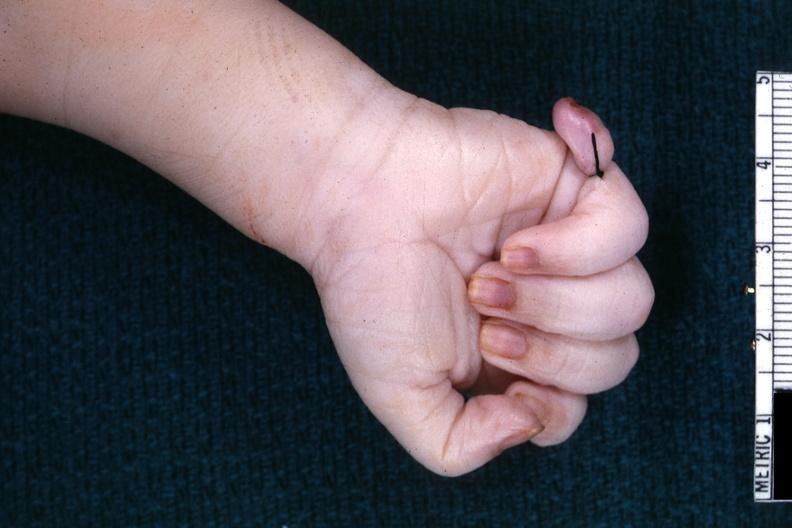s supernumerary digit present?
Answer the question using a single word or phrase. Yes 